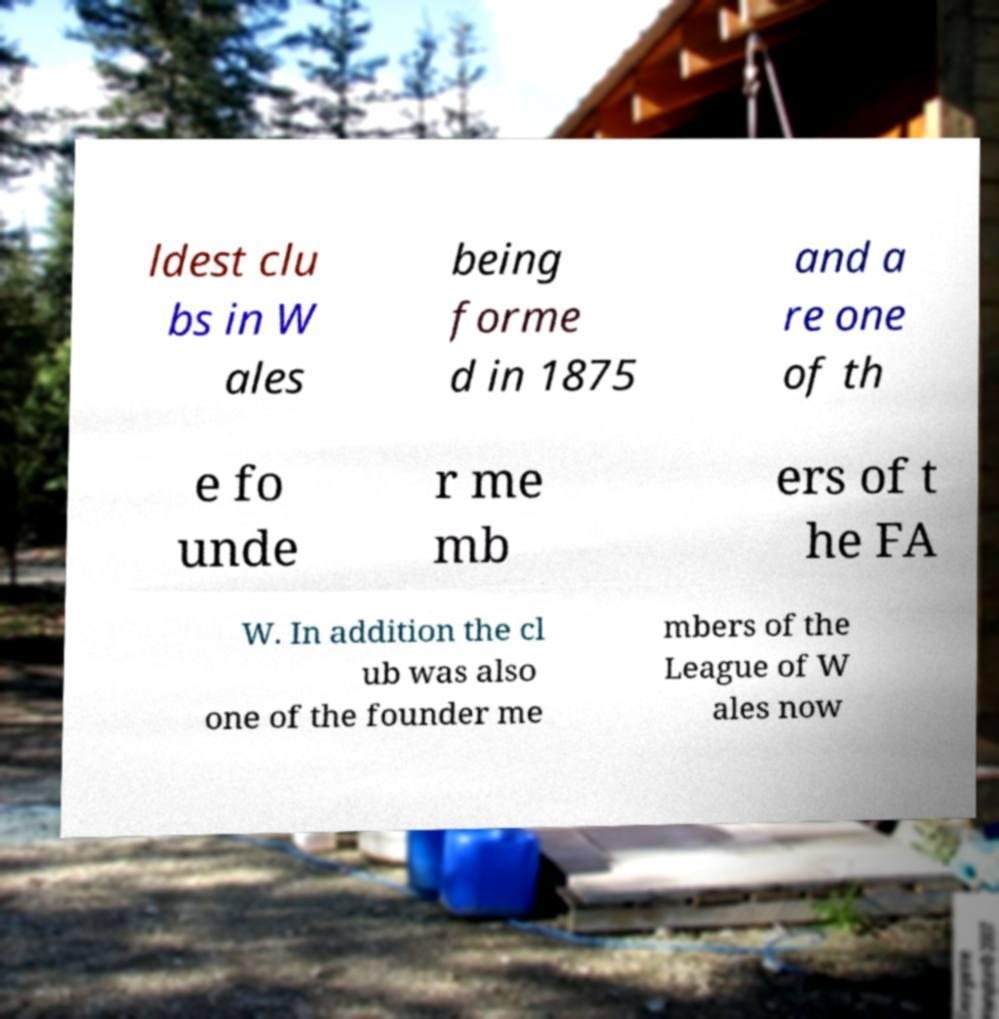I need the written content from this picture converted into text. Can you do that? ldest clu bs in W ales being forme d in 1875 and a re one of th e fo unde r me mb ers of t he FA W. In addition the cl ub was also one of the founder me mbers of the League of W ales now 